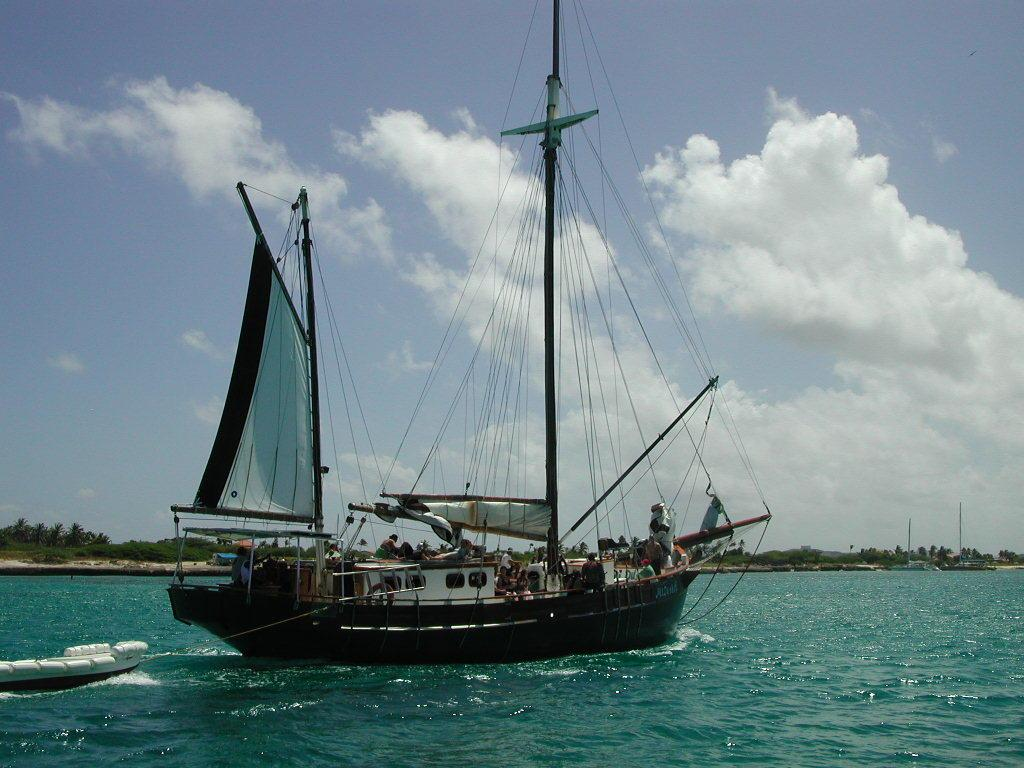What is the main subject of the image? The main subject of the image is a ship with people on it. What can be seen in the background of the image? There are trees and hills in the background of the image. What is the condition of the sky in the image? The sky in the image has clouds. What is visible at the bottom of the image? Water is visible at the bottom of the image. How much distribution of sea creatures can be seen in the image? There is no sea or sea creatures present in the image; it features a ship with people on it and a background with trees, hills, clouds, and water. 